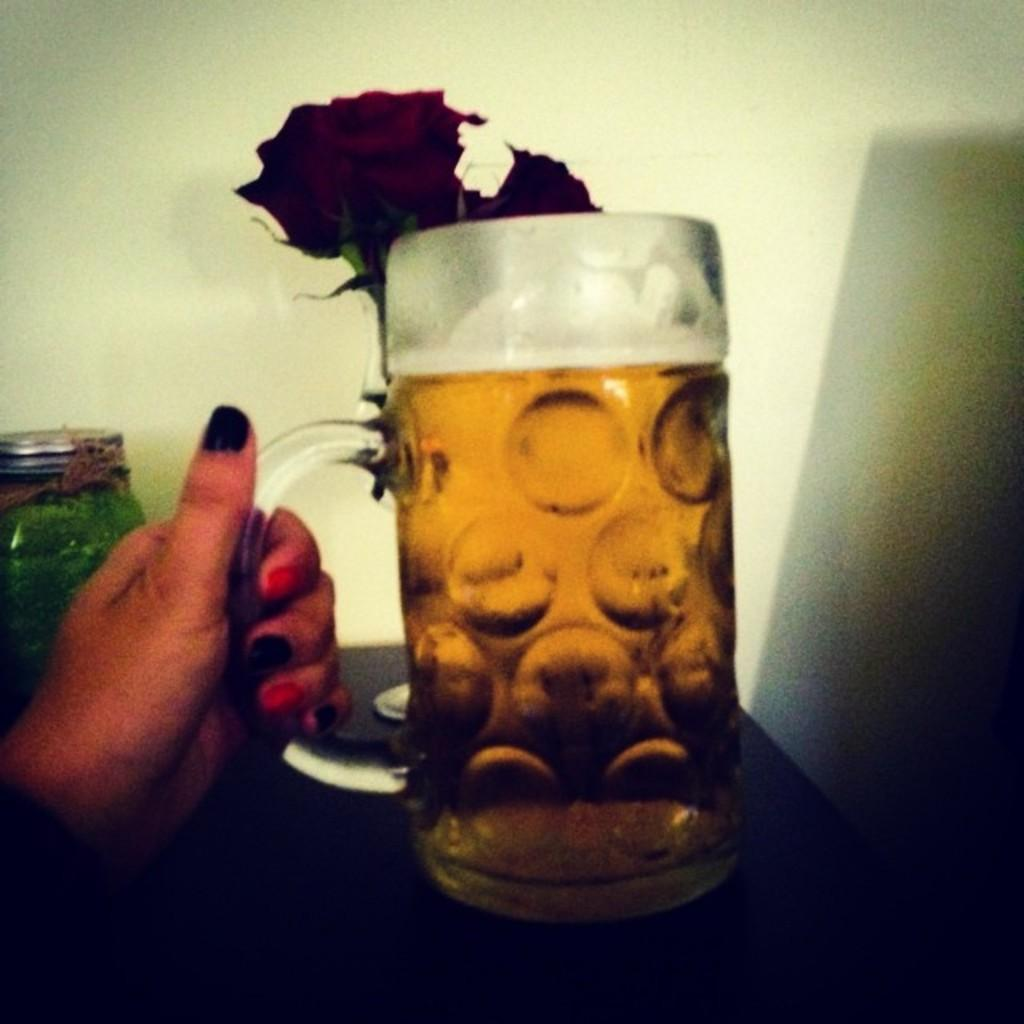What is the person in the image holding? The person is holding a glass in the image. What is inside the glass? The glass is filled with a drink. What can be seen on the table in the image? There is a jar and an object on the table in the image. Where is the table located in relation to the wall? The table is near a wall in the image. How many arms does the person have in the image? The number of arms the person has cannot be determined from the image, as only one arm is visible. What type of footwear is the person wearing in the image? There is no information about footwear in the image, as only the person's upper body is visible. 